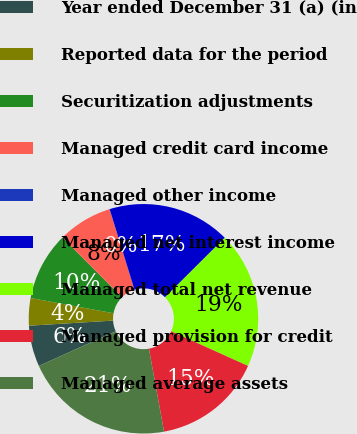Convert chart to OTSL. <chart><loc_0><loc_0><loc_500><loc_500><pie_chart><fcel>Year ended December 31 (a) (in<fcel>Reported data for the period<fcel>Securitization adjustments<fcel>Managed credit card income<fcel>Managed other income<fcel>Managed net interest income<fcel>Managed total net revenue<fcel>Managed provision for credit<fcel>Managed average assets<nl><fcel>5.78%<fcel>3.86%<fcel>9.62%<fcel>7.7%<fcel>0.02%<fcel>17.29%<fcel>19.21%<fcel>15.38%<fcel>21.13%<nl></chart> 